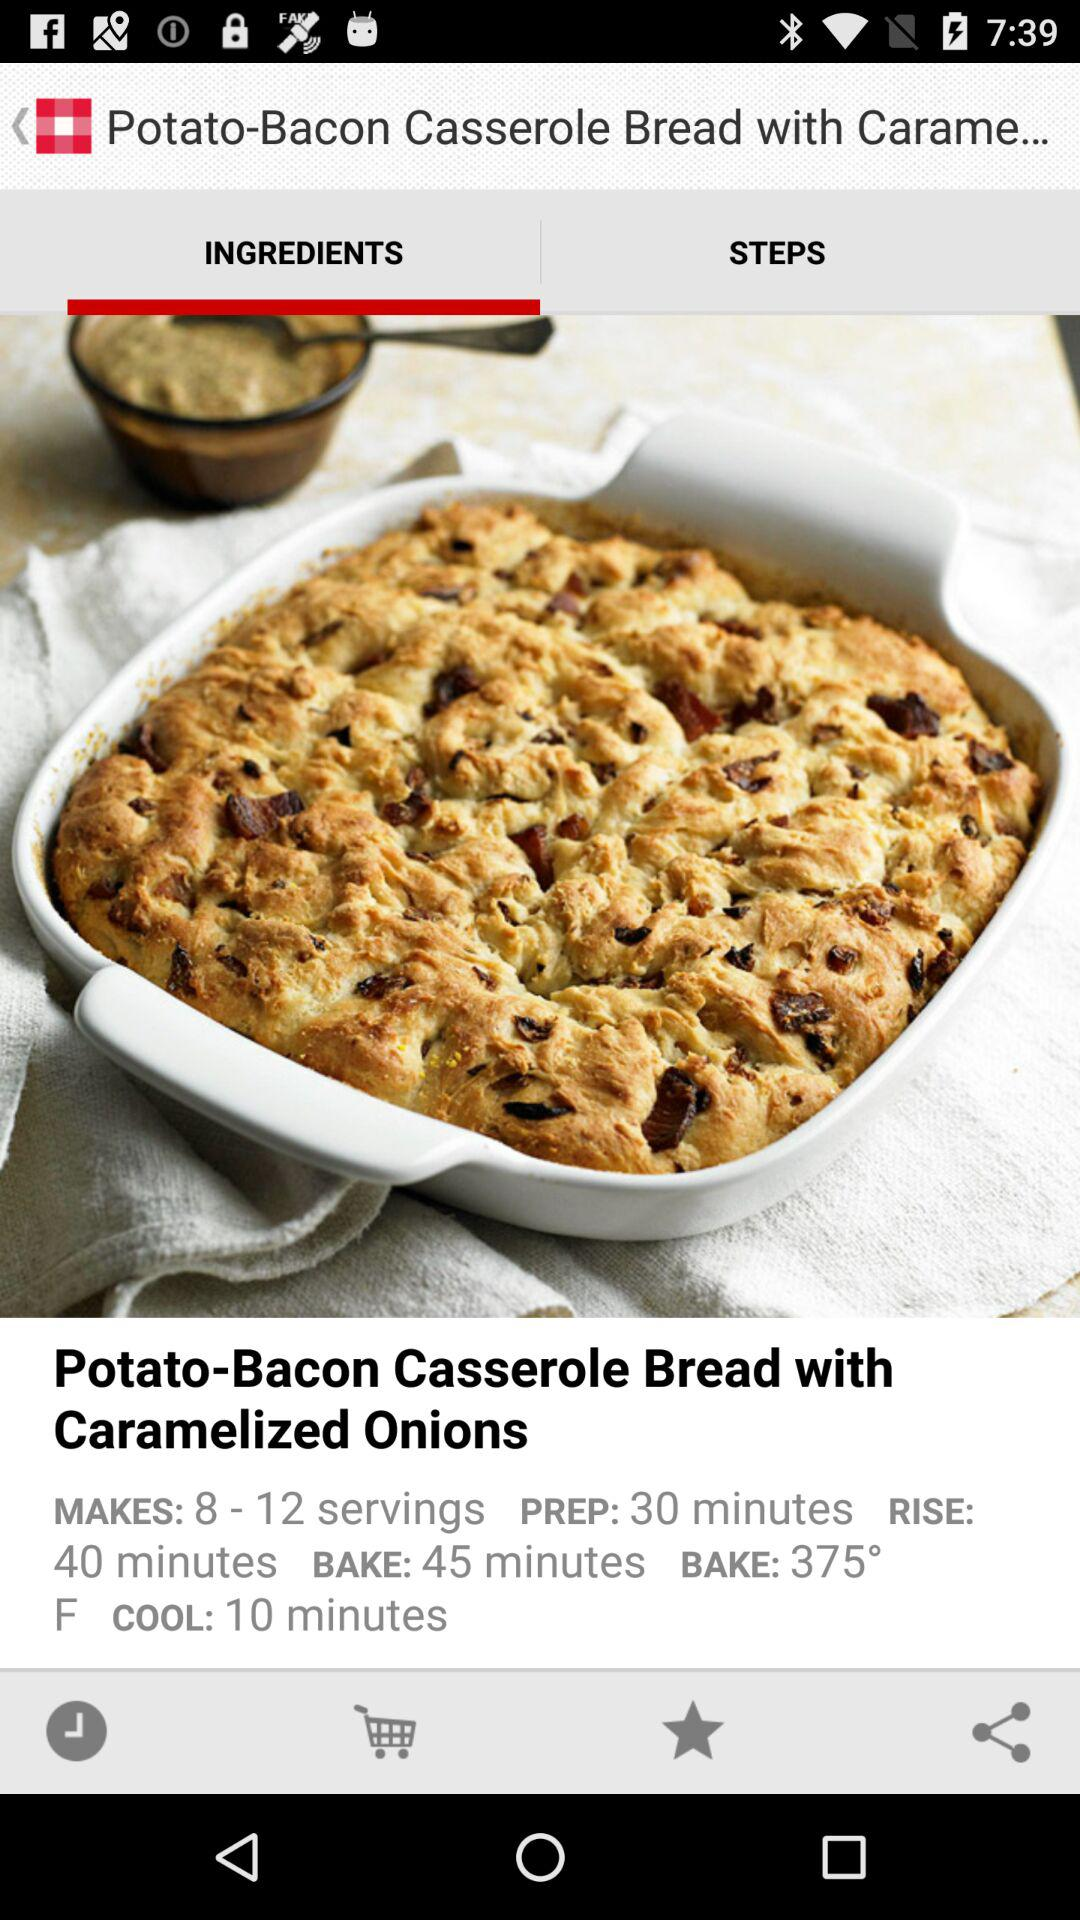How long does it take to bake? It takes 45 minutes to bake. 